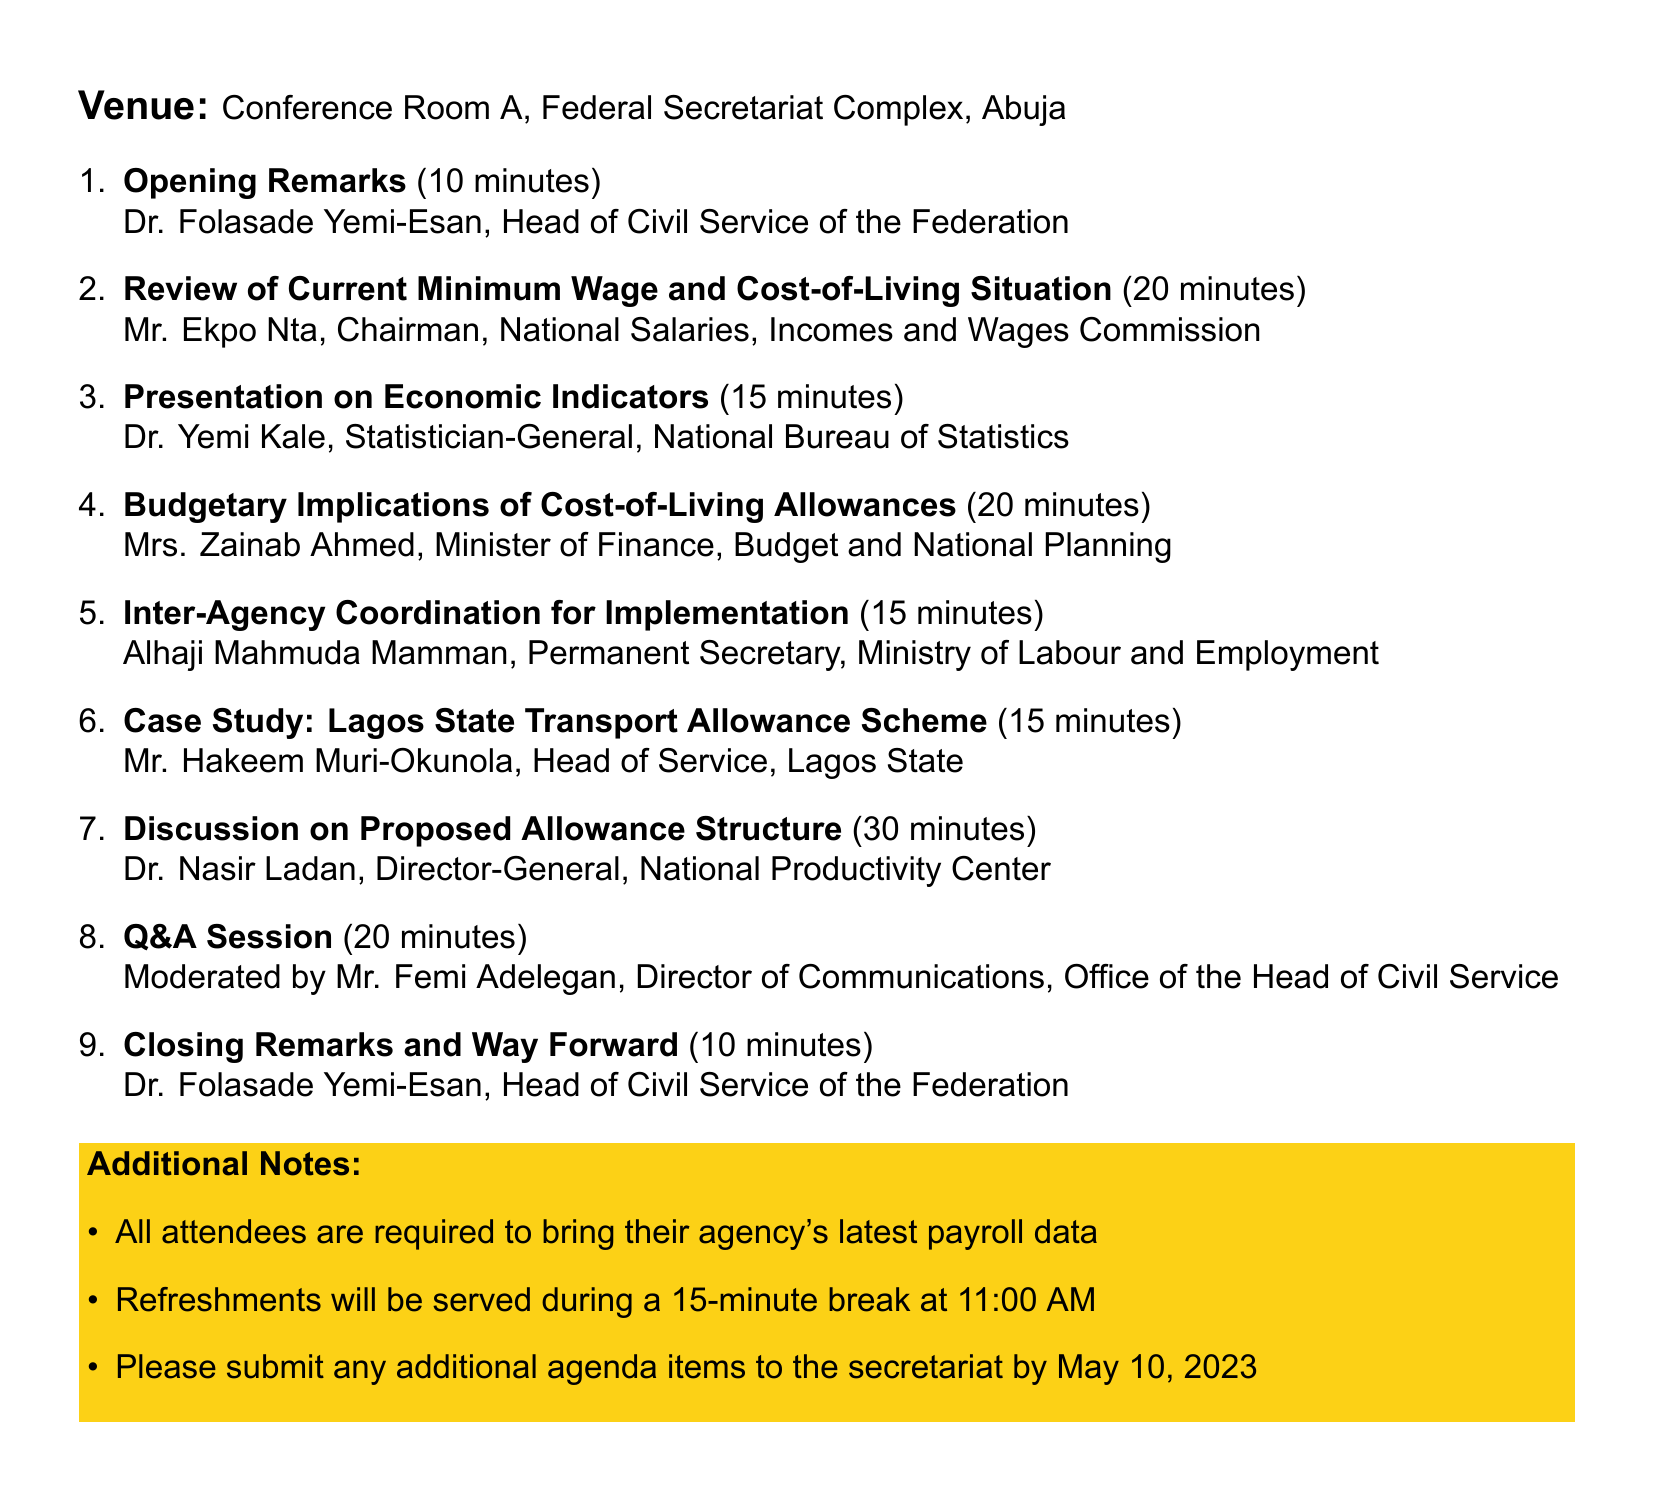What is the meeting title? The title of the meeting is presented at the top of the document, which is "Inter-Departmental Meeting on Cost-of-Living Allowances."
Answer: Inter-Departmental Meeting on Cost-of-Living Allowances Who is presenting the review of the current minimum wage and cost-of-living situation? The presenter for the agenda item on the current minimum wage and cost-of-living situation is mentioned in the document as Mr. Ekpo Nta.
Answer: Mr. Ekpo Nta What is the duration of the discussion on proposed allowance structure? The document lists the duration for the discussion on proposed allowance structure as 30 minutes.
Answer: 30 minutes What time does the meeting start? The start time of the meeting is indicated in the document.
Answer: 10:00 AM How long is the Q&A session? The duration of the Q&A session is specified in the agenda section of the document.
Answer: 20 minutes What will be served during the break? The document mentions what will be served during the break, specifically refreshments.
Answer: Refreshments Who moderates the Q&A session? The document indicates the moderator for the Q&A session, which is Mr. Femi Adelegan.
Answer: Mr. Femi Adelegan What is required from all attendees? The document details requirements for attendees in the additional notes section.
Answer: Latest payroll data What is the venue for the meeting? The document specifies the location of the meeting in the venue section.
Answer: Conference Room A, Federal Secretariat Complex, Abuja 